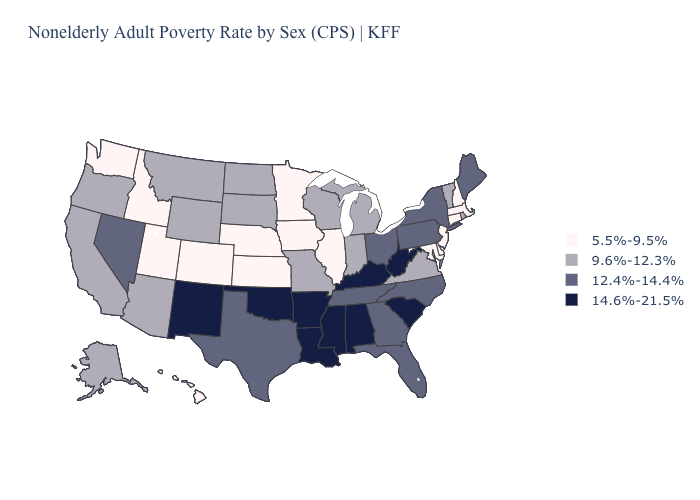Does Washington have a lower value than Nebraska?
Short answer required. No. What is the value of North Carolina?
Quick response, please. 12.4%-14.4%. What is the value of Illinois?
Write a very short answer. 5.5%-9.5%. Name the states that have a value in the range 5.5%-9.5%?
Short answer required. Colorado, Connecticut, Delaware, Hawaii, Idaho, Illinois, Iowa, Kansas, Maryland, Massachusetts, Minnesota, Nebraska, New Hampshire, New Jersey, Utah, Washington. What is the value of Delaware?
Be succinct. 5.5%-9.5%. Does New Hampshire have the lowest value in the Northeast?
Short answer required. Yes. How many symbols are there in the legend?
Concise answer only. 4. Which states hav the highest value in the Northeast?
Concise answer only. Maine, New York, Pennsylvania. How many symbols are there in the legend?
Write a very short answer. 4. Among the states that border North Carolina , does South Carolina have the highest value?
Write a very short answer. Yes. Does Massachusetts have the lowest value in the Northeast?
Keep it brief. Yes. What is the value of Arkansas?
Quick response, please. 14.6%-21.5%. Does New York have the highest value in the Northeast?
Concise answer only. Yes. What is the lowest value in the Northeast?
Quick response, please. 5.5%-9.5%. What is the value of Texas?
Short answer required. 12.4%-14.4%. 